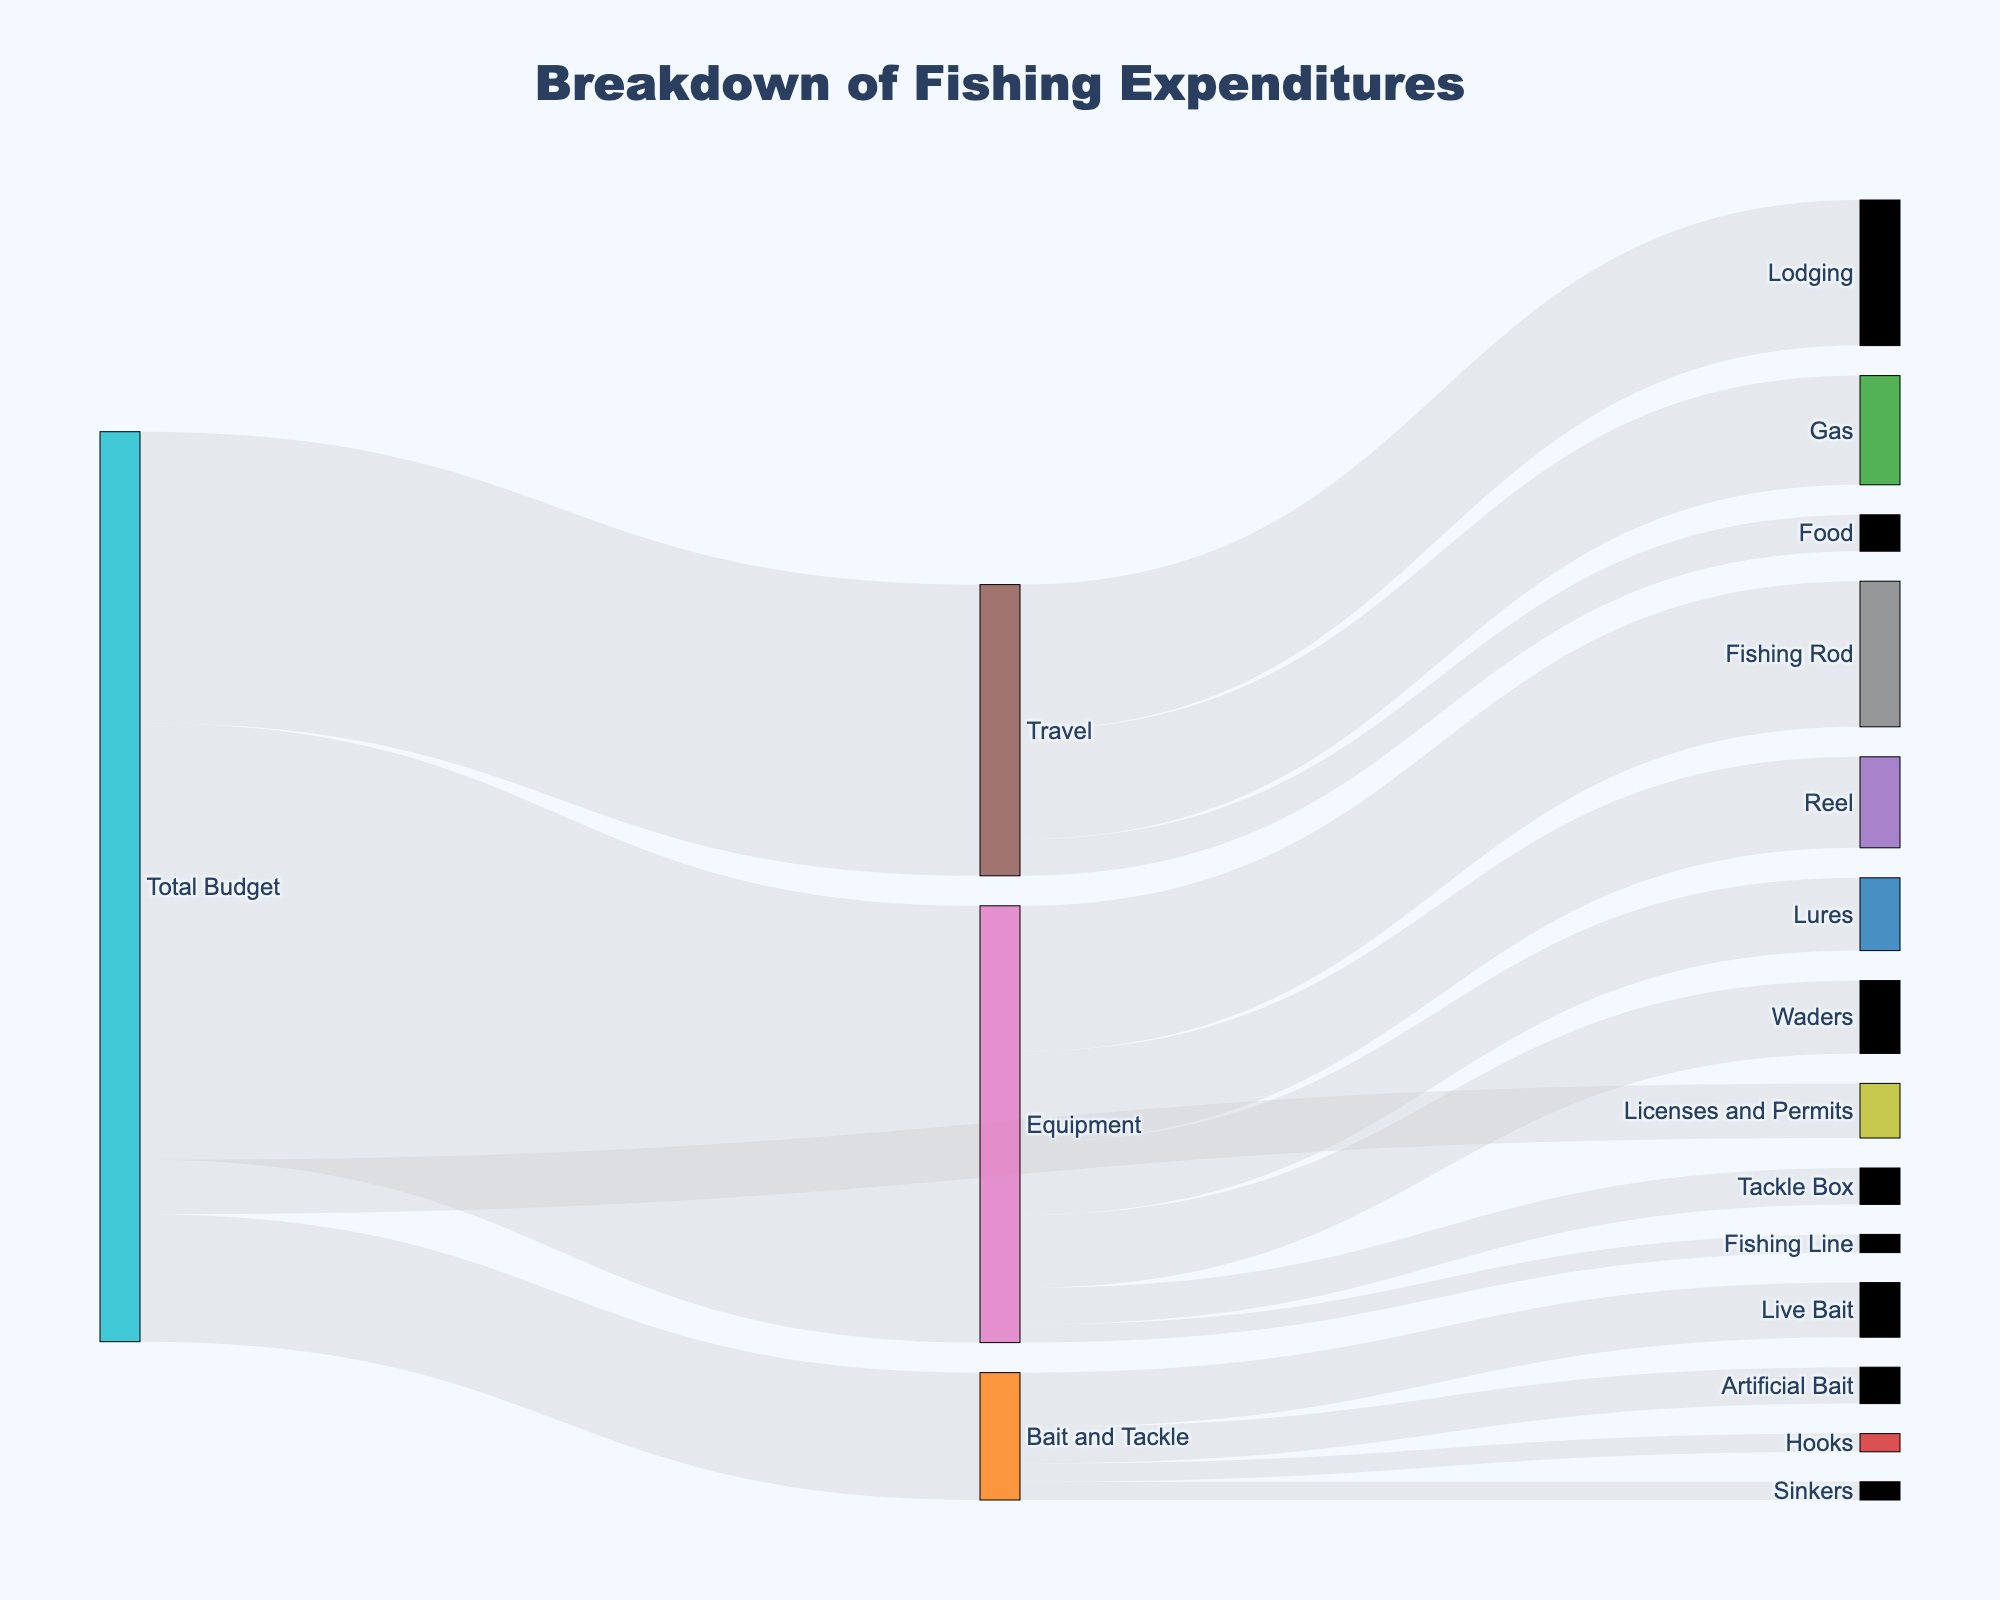what is the title of the figure? The title is usually at the top of the figure, and in this plot, it should clearly state the overall topic being visualized.
Answer: Breakdown of Fishing Expenditures How much of the total budget is spent on Equipment? Look at the flow from Total Budget to Equipment; the value represents the amount spent.
Answer: 1200 Which sub-category under Equipment has the highest expenditure? Follow the flows from Equipment to its sub-categories and identify the one with the highest value.
Answer: Fishing Rod How much is spent on Licenses and Permits relative to Bait and Tackle? Compare the value from Total Budget to Licenses and Permits with that from Total Budget to Bait and Tackle.
Answer: Less is spent on Licenses and Permits What is the combined cost of Gas and Lodging under Travel? Add the values from Travel to Gas and Travel to Lodging.
Answer: 300 + 400 = 700 Which category has the least expenditure under Bait and Tackle? Follow the flows from Bait and Tackle to its sub-categories and identify the one with the smallest value.
Answer: Hooks and Sinkers (both 50) What is the total amount spent on Travel-related expenses? Sum the values flowing from Travel to its sub-categories (Gas, Lodging, Food).
Answer: 300 + 400 + 100 = 800 How does the expenditure on Lures compare to that on Waders under Equipment? Compare the value from Equipment to Lures with that from Equipment to Waders.
Answer: They are equal (both 200) What is the percentage of the total budget allocated to Licenses and Permits? Divide the value for Licenses and Permits by the Total Budget and multiply by 100 to get the percentage. 150/2500 * 100
Answer: 6% Which category under Equipment has the lowest expenditure? Examine the flows from Equipment to its sub-categories and identify the one with the lowest value.
Answer: Fishing Line 